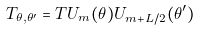Convert formula to latex. <formula><loc_0><loc_0><loc_500><loc_500>T _ { \theta , \theta ^ { \prime } } = T U _ { m } ( \theta ) U _ { m + L / 2 } ( \theta ^ { \prime } )</formula> 